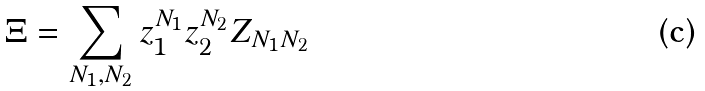<formula> <loc_0><loc_0><loc_500><loc_500>\Xi = \sum _ { N _ { 1 } , N _ { 2 } } z _ { 1 } ^ { N _ { 1 } } z _ { 2 } ^ { N _ { 2 } } Z _ { N _ { 1 } N _ { 2 } }</formula> 